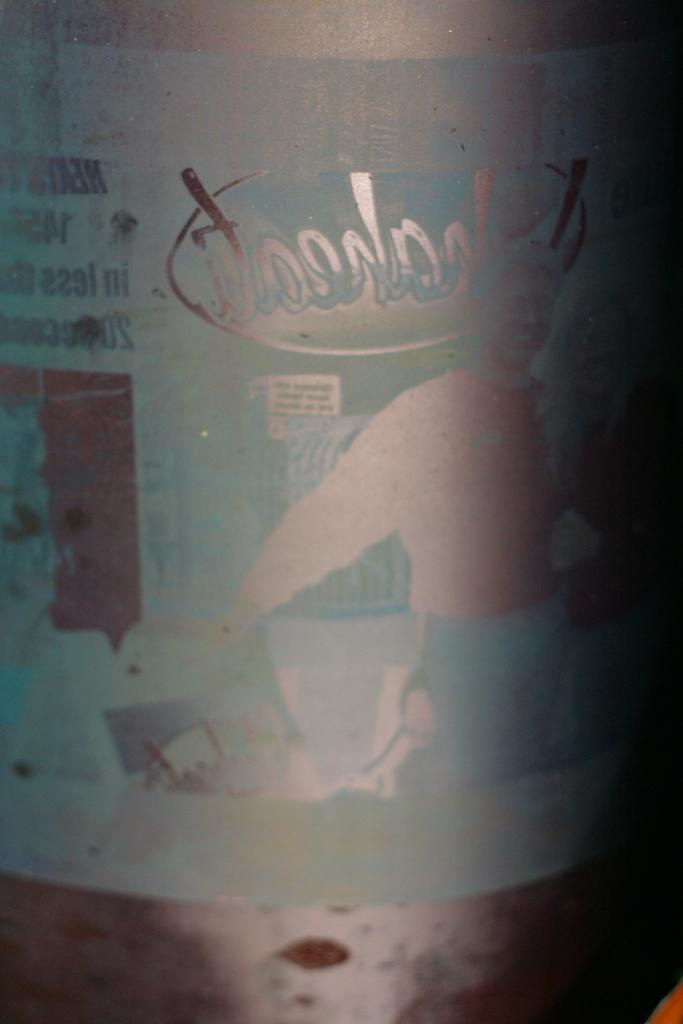What object can be seen in the image that is made of glass? There is a glass bottle in the image. What can be observed within the glass bottle? There are reflections of things visible in the glass bottle. What type of vest is being worn by the vegetable in the image? There is no vest or vegetable present in the image; it only features a glass bottle with reflections. 